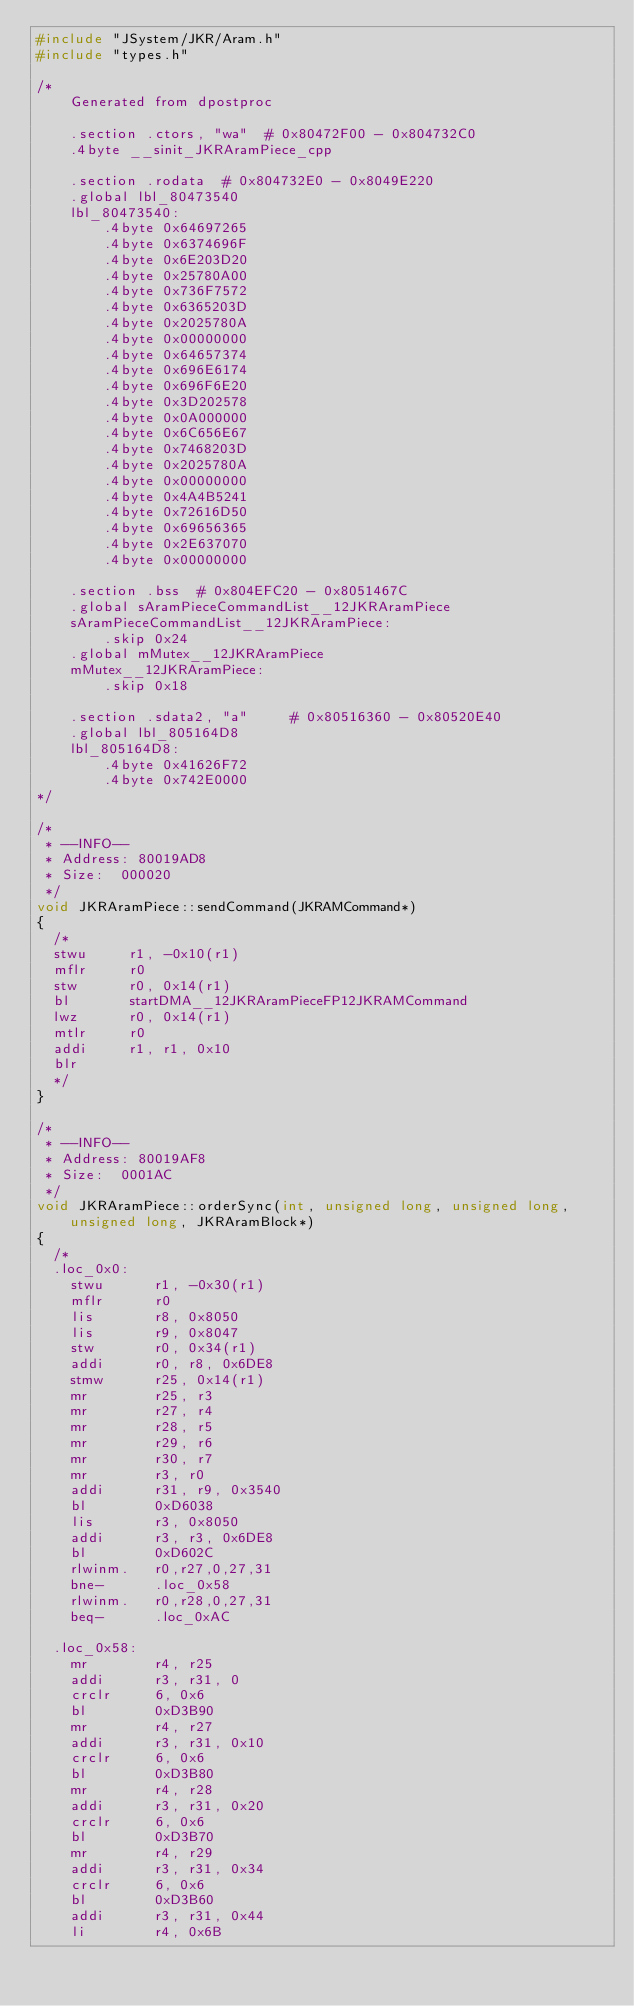<code> <loc_0><loc_0><loc_500><loc_500><_C++_>#include "JSystem/JKR/Aram.h"
#include "types.h"

/*
    Generated from dpostproc

    .section .ctors, "wa"  # 0x80472F00 - 0x804732C0
    .4byte __sinit_JKRAramPiece_cpp

    .section .rodata  # 0x804732E0 - 0x8049E220
    .global lbl_80473540
    lbl_80473540:
        .4byte 0x64697265
        .4byte 0x6374696F
        .4byte 0x6E203D20
        .4byte 0x25780A00
        .4byte 0x736F7572
        .4byte 0x6365203D
        .4byte 0x2025780A
        .4byte 0x00000000
        .4byte 0x64657374
        .4byte 0x696E6174
        .4byte 0x696F6E20
        .4byte 0x3D202578
        .4byte 0x0A000000
        .4byte 0x6C656E67
        .4byte 0x7468203D
        .4byte 0x2025780A
        .4byte 0x00000000
        .4byte 0x4A4B5241
        .4byte 0x72616D50
        .4byte 0x69656365
        .4byte 0x2E637070
        .4byte 0x00000000

    .section .bss  # 0x804EFC20 - 0x8051467C
    .global sAramPieceCommandList__12JKRAramPiece
    sAramPieceCommandList__12JKRAramPiece:
        .skip 0x24
    .global mMutex__12JKRAramPiece
    mMutex__12JKRAramPiece:
        .skip 0x18

    .section .sdata2, "a"     # 0x80516360 - 0x80520E40
    .global lbl_805164D8
    lbl_805164D8:
        .4byte 0x41626F72
        .4byte 0x742E0000
*/

/*
 * --INFO--
 * Address:	80019AD8
 * Size:	000020
 */
void JKRAramPiece::sendCommand(JKRAMCommand*)
{
	/*
	stwu     r1, -0x10(r1)
	mflr     r0
	stw      r0, 0x14(r1)
	bl       startDMA__12JKRAramPieceFP12JKRAMCommand
	lwz      r0, 0x14(r1)
	mtlr     r0
	addi     r1, r1, 0x10
	blr
	*/
}

/*
 * --INFO--
 * Address:	80019AF8
 * Size:	0001AC
 */
void JKRAramPiece::orderSync(int, unsigned long, unsigned long, unsigned long, JKRAramBlock*)
{
	/*
	.loc_0x0:
	  stwu      r1, -0x30(r1)
	  mflr      r0
	  lis       r8, 0x8050
	  lis       r9, 0x8047
	  stw       r0, 0x34(r1)
	  addi      r0, r8, 0x6DE8
	  stmw      r25, 0x14(r1)
	  mr        r25, r3
	  mr        r27, r4
	  mr        r28, r5
	  mr        r29, r6
	  mr        r30, r7
	  mr        r3, r0
	  addi      r31, r9, 0x3540
	  bl        0xD6038
	  lis       r3, 0x8050
	  addi      r3, r3, 0x6DE8
	  bl        0xD602C
	  rlwinm.   r0,r27,0,27,31
	  bne-      .loc_0x58
	  rlwinm.   r0,r28,0,27,31
	  beq-      .loc_0xAC

	.loc_0x58:
	  mr        r4, r25
	  addi      r3, r31, 0
	  crclr     6, 0x6
	  bl        0xD3B90
	  mr        r4, r27
	  addi      r3, r31, 0x10
	  crclr     6, 0x6
	  bl        0xD3B80
	  mr        r4, r28
	  addi      r3, r31, 0x20
	  crclr     6, 0x6
	  bl        0xD3B70
	  mr        r4, r29
	  addi      r3, r31, 0x34
	  crclr     6, 0x6
	  bl        0xD3B60
	  addi      r3, r31, 0x44
	  li        r4, 0x6B</code> 